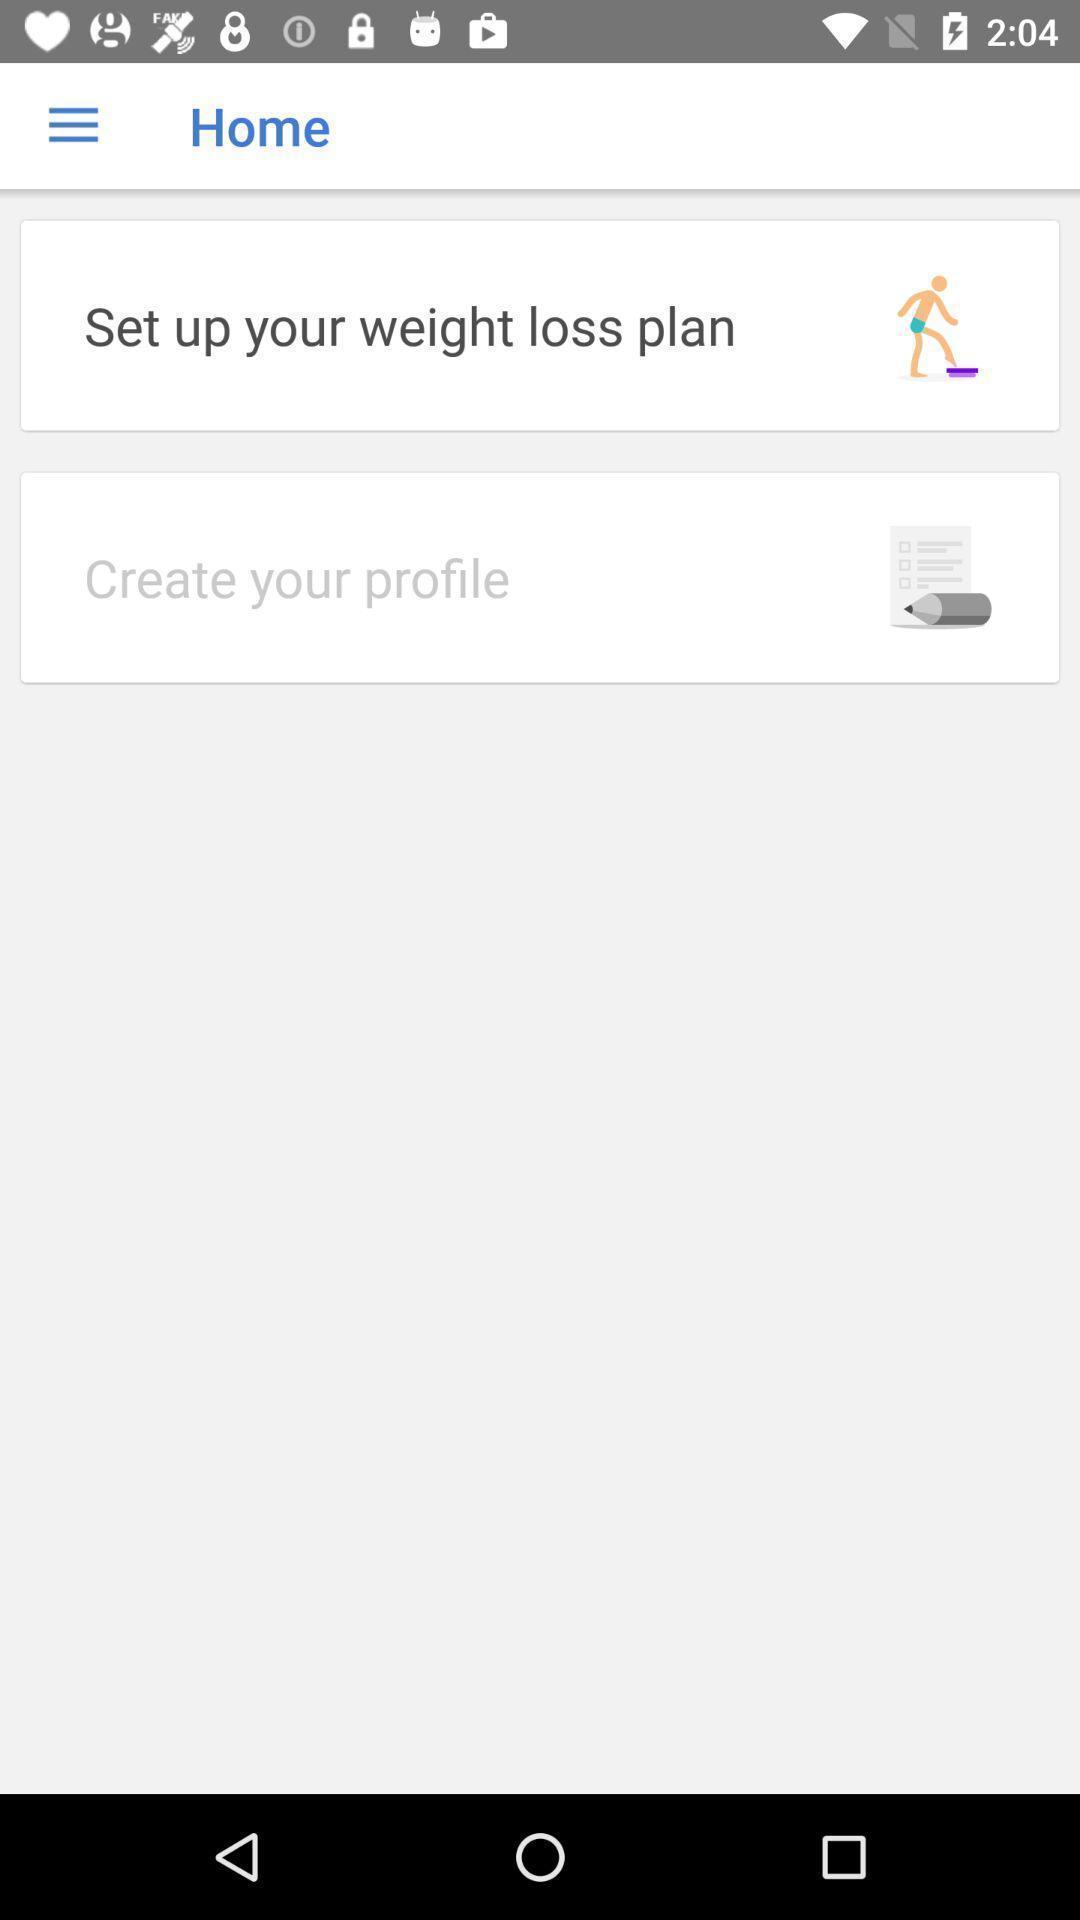Summarize the information in this screenshot. Window displaying an app for weight loss. 